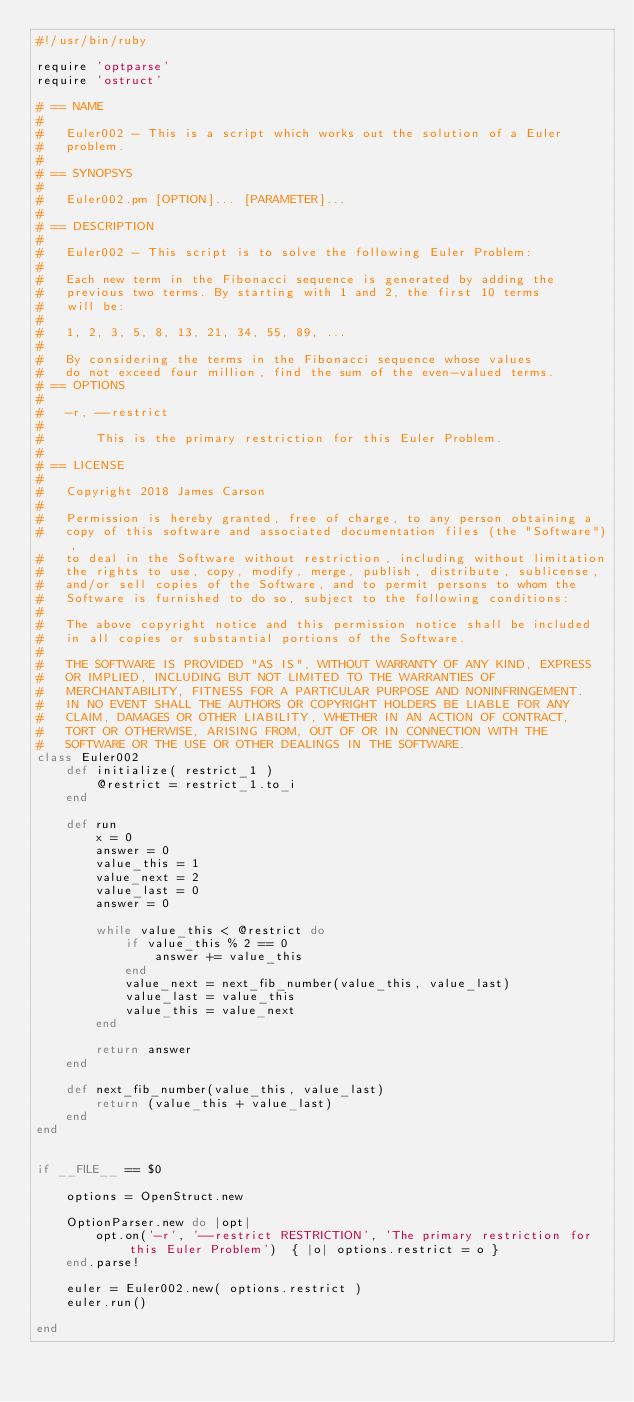<code> <loc_0><loc_0><loc_500><loc_500><_Ruby_>#!/usr/bin/ruby

require 'optparse'
require 'ostruct'

# == NAME
#
#   Euler002 - This is a script which works out the solution of a Euler
#   problem.
#
# == SYNOPSYS
#
#   Euler002.pm [OPTION]... [PARAMETER]...
#
# == DESCRIPTION
#
#   Euler002 - This script is to solve the following Euler Problem:
#
#   Each new term in the Fibonacci sequence is generated by adding the
#   previous two terms. By starting with 1 and 2, the first 10 terms
#   will be:
#
#   1, 2, 3, 5, 8, 13, 21, 34, 55, 89, ...
#
#   By considering the terms in the Fibonacci sequence whose values
#   do not exceed four million, find the sum of the even-valued terms.
# == OPTIONS
#
#   -r, --restrict
#
#       This is the primary restriction for this Euler Problem.
#
# == LICENSE
#
#   Copyright 2018 James Carson
#
#   Permission is hereby granted, free of charge, to any person obtaining a
#   copy of this software and associated documentation files (the "Software"),
#   to deal in the Software without restriction, including without limitation
#   the rights to use, copy, modify, merge, publish, distribute, sublicense,
#   and/or sell copies of the Software, and to permit persons to whom the
#   Software is furnished to do so, subject to the following conditions:
#
#   The above copyright notice and this permission notice shall be included
#   in all copies or substantial portions of the Software.
#
#   THE SOFTWARE IS PROVIDED "AS IS", WITHOUT WARRANTY OF ANY KIND, EXPRESS
#   OR IMPLIED, INCLUDING BUT NOT LIMITED TO THE WARRANTIES OF
#   MERCHANTABILITY, FITNESS FOR A PARTICULAR PURPOSE AND NONINFRINGEMENT.
#   IN NO EVENT SHALL THE AUTHORS OR COPYRIGHT HOLDERS BE LIABLE FOR ANY
#   CLAIM, DAMAGES OR OTHER LIABILITY, WHETHER IN AN ACTION OF CONTRACT,
#   TORT OR OTHERWISE, ARISING FROM, OUT OF OR IN CONNECTION WITH THE
#   SOFTWARE OR THE USE OR OTHER DEALINGS IN THE SOFTWARE.
class Euler002
    def initialize( restrict_1 )
        @restrict = restrict_1.to_i
    end

    def run
        x = 0
        answer = 0
        value_this = 1
        value_next = 2
        value_last = 0
        answer = 0

        while value_this < @restrict do
            if value_this % 2 == 0
                answer += value_this
            end
            value_next = next_fib_number(value_this, value_last)
            value_last = value_this
            value_this = value_next
        end

        return answer
    end

    def next_fib_number(value_this, value_last)
        return (value_this + value_last)
    end
end


if __FILE__ == $0

    options = OpenStruct.new

    OptionParser.new do |opt|
        opt.on('-r', '--restrict RESTRICTION', 'The primary restriction for this Euler Problem')  { |o| options.restrict = o }
    end.parse!

    euler = Euler002.new( options.restrict )
    euler.run()

end
</code> 